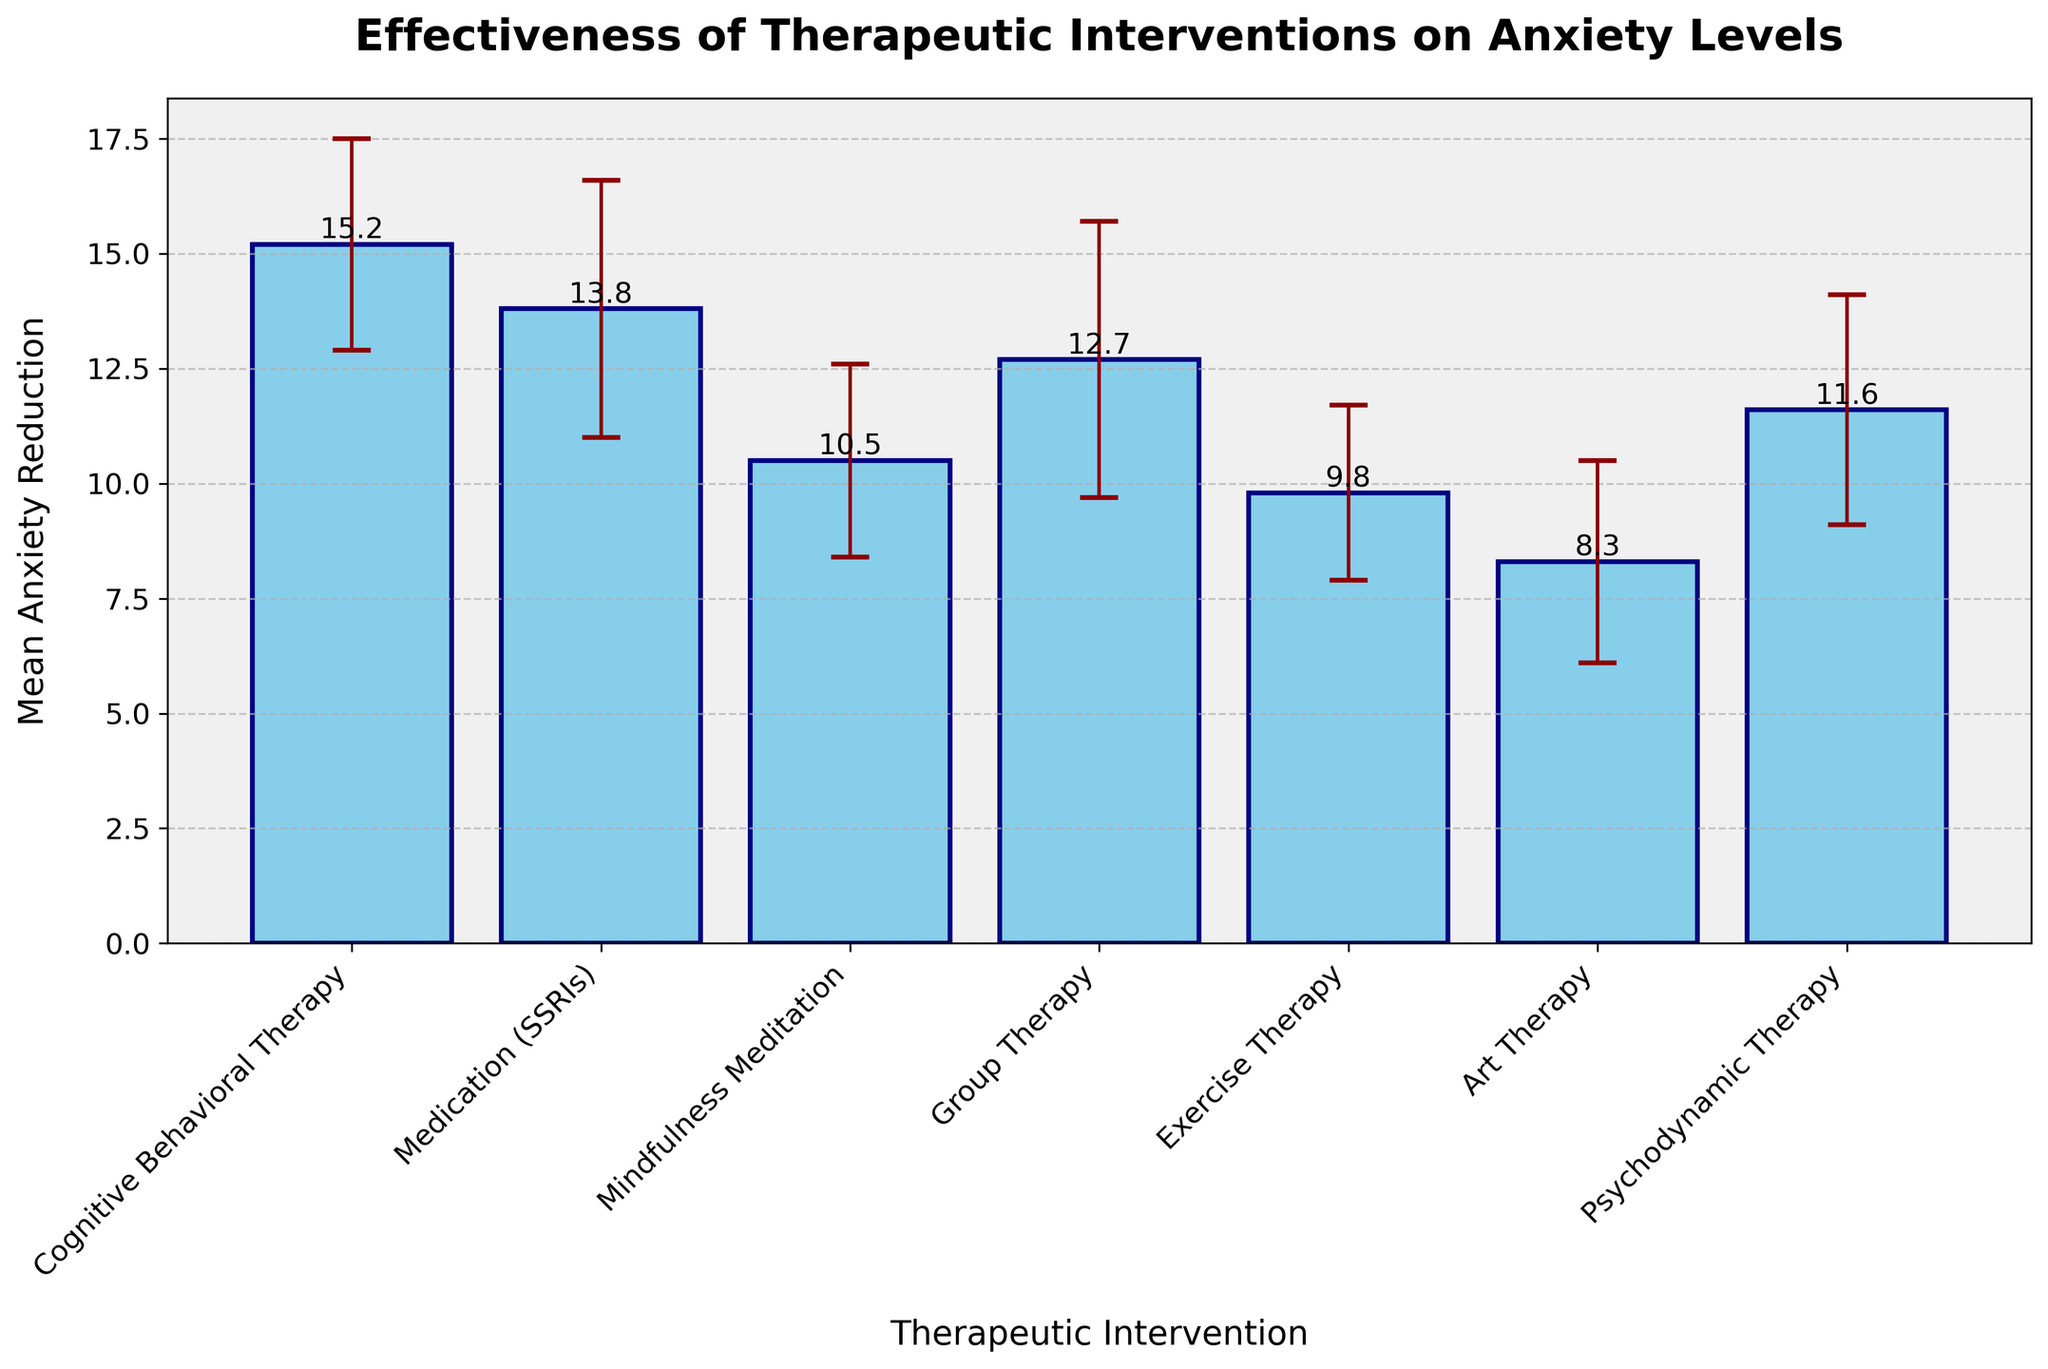What's the title of the plot? The title is noticeable at the top of the figure. It reads "Effectiveness of Therapeutic Interventions on Anxiety Levels".
Answer: Effectiveness of Therapeutic Interventions on Anxiety Levels Which therapeutic intervention shows the highest mean anxiety reduction? By examining the heights of the bars, Cognitive Behavioral Therapy (CBT) has the tallest bar, representing the highest mean anxiety reduction.
Answer: Cognitive Behavioral Therapy What is the mean anxiety reduction for Exercise Therapy? The height of the bar for Exercise Therapy shows a mean anxiety reduction of 9.8. This value is also labeled above the bar.
Answer: 9.8 Which therapeutic interventions have a mean anxiety reduction of more than 12? By analyzing the heights of the bars, Cognitive Behavioral Therapy, Medication (SSRIs), and Group Therapy each have bars reaching above the 12 mark.
Answer: Cognitive Behavioral Therapy, Medication (SSRIs), Group Therapy What is the average mean anxiety reduction of all interventions? First, sum the mean anxiety reductions (15.2 + 13.8 + 10.5 + 12.7 + 9.8 + 8.3 + 11.6 = 81.9). Then, divide by the number of interventions (81.9 / 7 ≈ 11.7).
Answer: 11.7 Comparing Group Therapy and Art Therapy, which has a higher standard deviation? The error bars represent standard deviations. Group Therapy has an error bar extending higher than that of Art Therapy, indicating a larger standard deviation.
Answer: Group Therapy Which intervention has the smallest standard deviation? By comparing the lengths of all error bars, Exercise Therapy has the shortest error bar, indicating the smallest standard deviation of 1.9.
Answer: Exercise Therapy What are the respective standard deviations for Cognitive Behavioral Therapy and Medication (SSRIs)? The lengths of the error bars show 2.3 for Cognitive Behavioral Therapy and 2.8 for Medication (SSRIs). These values are also stated in the data table.
Answer: 2.3 and 2.8 How does the mean anxiety reduction of Psychodynamic Therapy compare to that of Mindfulness Meditation? The bar for Psychodynamic Therapy (11.6) is slightly taller than that for Mindfulness Meditation (10.5), showing a higher mean anxiety reduction.
Answer: Psychodynamic Therapy is higher What's the total mean anxiety reduction of Cognitive Behavioral Therapy, Medication (SSRIs), and Group Therapy combined? Sum the mean anxiety reductions of these three interventions (15.2 + 13.8 + 12.7 = 41.7).
Answer: 41.7 